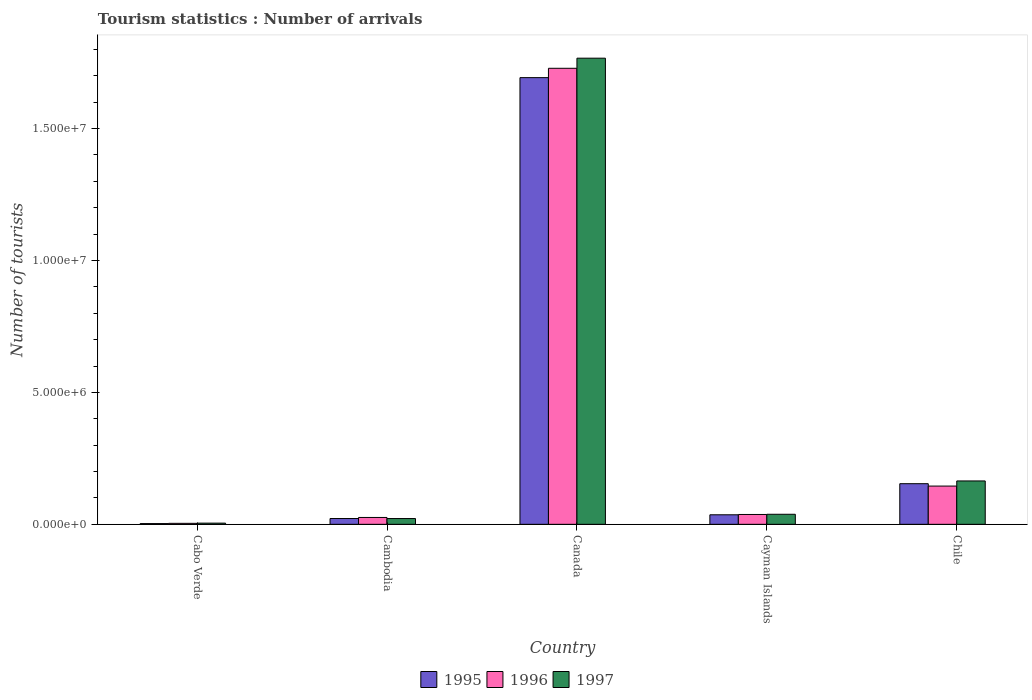Are the number of bars on each tick of the X-axis equal?
Your response must be concise. Yes. How many bars are there on the 1st tick from the left?
Offer a terse response. 3. What is the label of the 5th group of bars from the left?
Make the answer very short. Chile. What is the number of tourist arrivals in 1996 in Canada?
Your answer should be very brief. 1.73e+07. Across all countries, what is the maximum number of tourist arrivals in 1996?
Your answer should be compact. 1.73e+07. Across all countries, what is the minimum number of tourist arrivals in 1996?
Your answer should be compact. 3.70e+04. In which country was the number of tourist arrivals in 1995 minimum?
Offer a terse response. Cabo Verde. What is the total number of tourist arrivals in 1996 in the graph?
Offer a very short reply. 1.94e+07. What is the difference between the number of tourist arrivals in 1997 in Cabo Verde and that in Cambodia?
Ensure brevity in your answer.  -1.74e+05. What is the difference between the number of tourist arrivals in 1996 in Canada and the number of tourist arrivals in 1997 in Chile?
Your response must be concise. 1.56e+07. What is the average number of tourist arrivals in 1996 per country?
Keep it short and to the point. 3.88e+06. What is the difference between the number of tourist arrivals of/in 1996 and number of tourist arrivals of/in 1995 in Chile?
Make the answer very short. -9.00e+04. What is the ratio of the number of tourist arrivals in 1996 in Cambodia to that in Cayman Islands?
Keep it short and to the point. 0.7. Is the difference between the number of tourist arrivals in 1996 in Cayman Islands and Chile greater than the difference between the number of tourist arrivals in 1995 in Cayman Islands and Chile?
Make the answer very short. Yes. What is the difference between the highest and the second highest number of tourist arrivals in 1997?
Offer a terse response. 1.73e+07. What is the difference between the highest and the lowest number of tourist arrivals in 1997?
Offer a terse response. 1.76e+07. Is the sum of the number of tourist arrivals in 1995 in Canada and Chile greater than the maximum number of tourist arrivals in 1997 across all countries?
Your answer should be very brief. Yes. Is it the case that in every country, the sum of the number of tourist arrivals in 1997 and number of tourist arrivals in 1996 is greater than the number of tourist arrivals in 1995?
Your answer should be compact. Yes. Are all the bars in the graph horizontal?
Offer a terse response. No. How many countries are there in the graph?
Your response must be concise. 5. Are the values on the major ticks of Y-axis written in scientific E-notation?
Ensure brevity in your answer.  Yes. Does the graph contain any zero values?
Give a very brief answer. No. Does the graph contain grids?
Offer a very short reply. No. How many legend labels are there?
Make the answer very short. 3. How are the legend labels stacked?
Ensure brevity in your answer.  Horizontal. What is the title of the graph?
Give a very brief answer. Tourism statistics : Number of arrivals. Does "1969" appear as one of the legend labels in the graph?
Ensure brevity in your answer.  No. What is the label or title of the X-axis?
Make the answer very short. Country. What is the label or title of the Y-axis?
Offer a terse response. Number of tourists. What is the Number of tourists in 1995 in Cabo Verde?
Your answer should be compact. 2.80e+04. What is the Number of tourists of 1996 in Cabo Verde?
Your answer should be compact. 3.70e+04. What is the Number of tourists of 1997 in Cabo Verde?
Offer a terse response. 4.50e+04. What is the Number of tourists in 1997 in Cambodia?
Provide a short and direct response. 2.19e+05. What is the Number of tourists in 1995 in Canada?
Offer a very short reply. 1.69e+07. What is the Number of tourists of 1996 in Canada?
Provide a succinct answer. 1.73e+07. What is the Number of tourists of 1997 in Canada?
Your response must be concise. 1.77e+07. What is the Number of tourists of 1995 in Cayman Islands?
Provide a succinct answer. 3.61e+05. What is the Number of tourists in 1996 in Cayman Islands?
Offer a very short reply. 3.73e+05. What is the Number of tourists of 1997 in Cayman Islands?
Provide a short and direct response. 3.81e+05. What is the Number of tourists in 1995 in Chile?
Give a very brief answer. 1.54e+06. What is the Number of tourists in 1996 in Chile?
Your response must be concise. 1.45e+06. What is the Number of tourists in 1997 in Chile?
Provide a succinct answer. 1.64e+06. Across all countries, what is the maximum Number of tourists of 1995?
Provide a succinct answer. 1.69e+07. Across all countries, what is the maximum Number of tourists in 1996?
Make the answer very short. 1.73e+07. Across all countries, what is the maximum Number of tourists in 1997?
Your answer should be compact. 1.77e+07. Across all countries, what is the minimum Number of tourists in 1995?
Ensure brevity in your answer.  2.80e+04. Across all countries, what is the minimum Number of tourists in 1996?
Your answer should be very brief. 3.70e+04. Across all countries, what is the minimum Number of tourists in 1997?
Give a very brief answer. 4.50e+04. What is the total Number of tourists in 1995 in the graph?
Provide a short and direct response. 1.91e+07. What is the total Number of tourists of 1996 in the graph?
Offer a very short reply. 1.94e+07. What is the total Number of tourists in 1997 in the graph?
Provide a short and direct response. 2.00e+07. What is the difference between the Number of tourists of 1995 in Cabo Verde and that in Cambodia?
Your response must be concise. -1.92e+05. What is the difference between the Number of tourists in 1996 in Cabo Verde and that in Cambodia?
Your answer should be very brief. -2.23e+05. What is the difference between the Number of tourists in 1997 in Cabo Verde and that in Cambodia?
Your answer should be very brief. -1.74e+05. What is the difference between the Number of tourists of 1995 in Cabo Verde and that in Canada?
Keep it short and to the point. -1.69e+07. What is the difference between the Number of tourists of 1996 in Cabo Verde and that in Canada?
Offer a terse response. -1.72e+07. What is the difference between the Number of tourists of 1997 in Cabo Verde and that in Canada?
Your answer should be very brief. -1.76e+07. What is the difference between the Number of tourists in 1995 in Cabo Verde and that in Cayman Islands?
Keep it short and to the point. -3.33e+05. What is the difference between the Number of tourists of 1996 in Cabo Verde and that in Cayman Islands?
Keep it short and to the point. -3.36e+05. What is the difference between the Number of tourists in 1997 in Cabo Verde and that in Cayman Islands?
Keep it short and to the point. -3.36e+05. What is the difference between the Number of tourists in 1995 in Cabo Verde and that in Chile?
Your response must be concise. -1.51e+06. What is the difference between the Number of tourists of 1996 in Cabo Verde and that in Chile?
Offer a very short reply. -1.41e+06. What is the difference between the Number of tourists in 1997 in Cabo Verde and that in Chile?
Your response must be concise. -1.60e+06. What is the difference between the Number of tourists of 1995 in Cambodia and that in Canada?
Keep it short and to the point. -1.67e+07. What is the difference between the Number of tourists of 1996 in Cambodia and that in Canada?
Provide a succinct answer. -1.70e+07. What is the difference between the Number of tourists of 1997 in Cambodia and that in Canada?
Make the answer very short. -1.74e+07. What is the difference between the Number of tourists of 1995 in Cambodia and that in Cayman Islands?
Give a very brief answer. -1.41e+05. What is the difference between the Number of tourists in 1996 in Cambodia and that in Cayman Islands?
Ensure brevity in your answer.  -1.13e+05. What is the difference between the Number of tourists in 1997 in Cambodia and that in Cayman Islands?
Ensure brevity in your answer.  -1.62e+05. What is the difference between the Number of tourists in 1995 in Cambodia and that in Chile?
Provide a short and direct response. -1.32e+06. What is the difference between the Number of tourists of 1996 in Cambodia and that in Chile?
Your answer should be compact. -1.19e+06. What is the difference between the Number of tourists of 1997 in Cambodia and that in Chile?
Your response must be concise. -1.42e+06. What is the difference between the Number of tourists in 1995 in Canada and that in Cayman Islands?
Keep it short and to the point. 1.66e+07. What is the difference between the Number of tourists in 1996 in Canada and that in Cayman Islands?
Make the answer very short. 1.69e+07. What is the difference between the Number of tourists of 1997 in Canada and that in Cayman Islands?
Keep it short and to the point. 1.73e+07. What is the difference between the Number of tourists of 1995 in Canada and that in Chile?
Your answer should be compact. 1.54e+07. What is the difference between the Number of tourists of 1996 in Canada and that in Chile?
Keep it short and to the point. 1.58e+07. What is the difference between the Number of tourists in 1997 in Canada and that in Chile?
Offer a terse response. 1.60e+07. What is the difference between the Number of tourists in 1995 in Cayman Islands and that in Chile?
Provide a succinct answer. -1.18e+06. What is the difference between the Number of tourists of 1996 in Cayman Islands and that in Chile?
Give a very brief answer. -1.08e+06. What is the difference between the Number of tourists of 1997 in Cayman Islands and that in Chile?
Your response must be concise. -1.26e+06. What is the difference between the Number of tourists in 1995 in Cabo Verde and the Number of tourists in 1996 in Cambodia?
Offer a terse response. -2.32e+05. What is the difference between the Number of tourists of 1995 in Cabo Verde and the Number of tourists of 1997 in Cambodia?
Ensure brevity in your answer.  -1.91e+05. What is the difference between the Number of tourists of 1996 in Cabo Verde and the Number of tourists of 1997 in Cambodia?
Your answer should be very brief. -1.82e+05. What is the difference between the Number of tourists of 1995 in Cabo Verde and the Number of tourists of 1996 in Canada?
Offer a very short reply. -1.73e+07. What is the difference between the Number of tourists in 1995 in Cabo Verde and the Number of tourists in 1997 in Canada?
Ensure brevity in your answer.  -1.76e+07. What is the difference between the Number of tourists of 1996 in Cabo Verde and the Number of tourists of 1997 in Canada?
Keep it short and to the point. -1.76e+07. What is the difference between the Number of tourists in 1995 in Cabo Verde and the Number of tourists in 1996 in Cayman Islands?
Provide a succinct answer. -3.45e+05. What is the difference between the Number of tourists of 1995 in Cabo Verde and the Number of tourists of 1997 in Cayman Islands?
Make the answer very short. -3.53e+05. What is the difference between the Number of tourists in 1996 in Cabo Verde and the Number of tourists in 1997 in Cayman Islands?
Make the answer very short. -3.44e+05. What is the difference between the Number of tourists in 1995 in Cabo Verde and the Number of tourists in 1996 in Chile?
Ensure brevity in your answer.  -1.42e+06. What is the difference between the Number of tourists of 1995 in Cabo Verde and the Number of tourists of 1997 in Chile?
Your response must be concise. -1.62e+06. What is the difference between the Number of tourists of 1996 in Cabo Verde and the Number of tourists of 1997 in Chile?
Provide a succinct answer. -1.61e+06. What is the difference between the Number of tourists of 1995 in Cambodia and the Number of tourists of 1996 in Canada?
Keep it short and to the point. -1.71e+07. What is the difference between the Number of tourists in 1995 in Cambodia and the Number of tourists in 1997 in Canada?
Offer a very short reply. -1.74e+07. What is the difference between the Number of tourists in 1996 in Cambodia and the Number of tourists in 1997 in Canada?
Give a very brief answer. -1.74e+07. What is the difference between the Number of tourists in 1995 in Cambodia and the Number of tourists in 1996 in Cayman Islands?
Give a very brief answer. -1.53e+05. What is the difference between the Number of tourists of 1995 in Cambodia and the Number of tourists of 1997 in Cayman Islands?
Your answer should be very brief. -1.61e+05. What is the difference between the Number of tourists in 1996 in Cambodia and the Number of tourists in 1997 in Cayman Islands?
Offer a very short reply. -1.21e+05. What is the difference between the Number of tourists in 1995 in Cambodia and the Number of tourists in 1996 in Chile?
Keep it short and to the point. -1.23e+06. What is the difference between the Number of tourists of 1995 in Cambodia and the Number of tourists of 1997 in Chile?
Your answer should be compact. -1.42e+06. What is the difference between the Number of tourists in 1996 in Cambodia and the Number of tourists in 1997 in Chile?
Your answer should be very brief. -1.38e+06. What is the difference between the Number of tourists in 1995 in Canada and the Number of tourists in 1996 in Cayman Islands?
Keep it short and to the point. 1.66e+07. What is the difference between the Number of tourists of 1995 in Canada and the Number of tourists of 1997 in Cayman Islands?
Offer a terse response. 1.66e+07. What is the difference between the Number of tourists of 1996 in Canada and the Number of tourists of 1997 in Cayman Islands?
Provide a succinct answer. 1.69e+07. What is the difference between the Number of tourists in 1995 in Canada and the Number of tourists in 1996 in Chile?
Provide a succinct answer. 1.55e+07. What is the difference between the Number of tourists in 1995 in Canada and the Number of tourists in 1997 in Chile?
Ensure brevity in your answer.  1.53e+07. What is the difference between the Number of tourists of 1996 in Canada and the Number of tourists of 1997 in Chile?
Make the answer very short. 1.56e+07. What is the difference between the Number of tourists in 1995 in Cayman Islands and the Number of tourists in 1996 in Chile?
Provide a succinct answer. -1.09e+06. What is the difference between the Number of tourists of 1995 in Cayman Islands and the Number of tourists of 1997 in Chile?
Your answer should be compact. -1.28e+06. What is the difference between the Number of tourists in 1996 in Cayman Islands and the Number of tourists in 1997 in Chile?
Your response must be concise. -1.27e+06. What is the average Number of tourists of 1995 per country?
Provide a succinct answer. 3.82e+06. What is the average Number of tourists of 1996 per country?
Provide a short and direct response. 3.88e+06. What is the average Number of tourists in 1997 per country?
Your response must be concise. 3.99e+06. What is the difference between the Number of tourists of 1995 and Number of tourists of 1996 in Cabo Verde?
Your response must be concise. -9000. What is the difference between the Number of tourists in 1995 and Number of tourists in 1997 in Cabo Verde?
Your response must be concise. -1.70e+04. What is the difference between the Number of tourists of 1996 and Number of tourists of 1997 in Cabo Verde?
Keep it short and to the point. -8000. What is the difference between the Number of tourists of 1995 and Number of tourists of 1996 in Cambodia?
Your answer should be compact. -4.00e+04. What is the difference between the Number of tourists of 1995 and Number of tourists of 1997 in Cambodia?
Ensure brevity in your answer.  1000. What is the difference between the Number of tourists in 1996 and Number of tourists in 1997 in Cambodia?
Provide a succinct answer. 4.10e+04. What is the difference between the Number of tourists in 1995 and Number of tourists in 1996 in Canada?
Offer a very short reply. -3.54e+05. What is the difference between the Number of tourists in 1995 and Number of tourists in 1997 in Canada?
Make the answer very short. -7.37e+05. What is the difference between the Number of tourists in 1996 and Number of tourists in 1997 in Canada?
Offer a very short reply. -3.83e+05. What is the difference between the Number of tourists of 1995 and Number of tourists of 1996 in Cayman Islands?
Offer a terse response. -1.20e+04. What is the difference between the Number of tourists in 1995 and Number of tourists in 1997 in Cayman Islands?
Your answer should be compact. -2.00e+04. What is the difference between the Number of tourists in 1996 and Number of tourists in 1997 in Cayman Islands?
Your answer should be compact. -8000. What is the difference between the Number of tourists of 1995 and Number of tourists of 1996 in Chile?
Offer a very short reply. 9.00e+04. What is the difference between the Number of tourists in 1995 and Number of tourists in 1997 in Chile?
Ensure brevity in your answer.  -1.04e+05. What is the difference between the Number of tourists in 1996 and Number of tourists in 1997 in Chile?
Provide a short and direct response. -1.94e+05. What is the ratio of the Number of tourists of 1995 in Cabo Verde to that in Cambodia?
Give a very brief answer. 0.13. What is the ratio of the Number of tourists in 1996 in Cabo Verde to that in Cambodia?
Your response must be concise. 0.14. What is the ratio of the Number of tourists of 1997 in Cabo Verde to that in Cambodia?
Your response must be concise. 0.21. What is the ratio of the Number of tourists of 1995 in Cabo Verde to that in Canada?
Your answer should be very brief. 0. What is the ratio of the Number of tourists of 1996 in Cabo Verde to that in Canada?
Your answer should be very brief. 0. What is the ratio of the Number of tourists in 1997 in Cabo Verde to that in Canada?
Your response must be concise. 0. What is the ratio of the Number of tourists in 1995 in Cabo Verde to that in Cayman Islands?
Ensure brevity in your answer.  0.08. What is the ratio of the Number of tourists in 1996 in Cabo Verde to that in Cayman Islands?
Your response must be concise. 0.1. What is the ratio of the Number of tourists of 1997 in Cabo Verde to that in Cayman Islands?
Keep it short and to the point. 0.12. What is the ratio of the Number of tourists of 1995 in Cabo Verde to that in Chile?
Offer a very short reply. 0.02. What is the ratio of the Number of tourists in 1996 in Cabo Verde to that in Chile?
Make the answer very short. 0.03. What is the ratio of the Number of tourists in 1997 in Cabo Verde to that in Chile?
Keep it short and to the point. 0.03. What is the ratio of the Number of tourists in 1995 in Cambodia to that in Canada?
Give a very brief answer. 0.01. What is the ratio of the Number of tourists of 1996 in Cambodia to that in Canada?
Offer a very short reply. 0.01. What is the ratio of the Number of tourists in 1997 in Cambodia to that in Canada?
Ensure brevity in your answer.  0.01. What is the ratio of the Number of tourists in 1995 in Cambodia to that in Cayman Islands?
Give a very brief answer. 0.61. What is the ratio of the Number of tourists of 1996 in Cambodia to that in Cayman Islands?
Your answer should be very brief. 0.7. What is the ratio of the Number of tourists of 1997 in Cambodia to that in Cayman Islands?
Make the answer very short. 0.57. What is the ratio of the Number of tourists in 1995 in Cambodia to that in Chile?
Your answer should be compact. 0.14. What is the ratio of the Number of tourists of 1996 in Cambodia to that in Chile?
Offer a terse response. 0.18. What is the ratio of the Number of tourists of 1997 in Cambodia to that in Chile?
Ensure brevity in your answer.  0.13. What is the ratio of the Number of tourists in 1995 in Canada to that in Cayman Islands?
Keep it short and to the point. 46.9. What is the ratio of the Number of tourists in 1996 in Canada to that in Cayman Islands?
Provide a short and direct response. 46.34. What is the ratio of the Number of tourists of 1997 in Canada to that in Cayman Islands?
Provide a short and direct response. 46.38. What is the ratio of the Number of tourists of 1995 in Canada to that in Chile?
Provide a short and direct response. 10.99. What is the ratio of the Number of tourists in 1996 in Canada to that in Chile?
Your answer should be very brief. 11.92. What is the ratio of the Number of tourists of 1997 in Canada to that in Chile?
Ensure brevity in your answer.  10.75. What is the ratio of the Number of tourists in 1995 in Cayman Islands to that in Chile?
Your answer should be compact. 0.23. What is the ratio of the Number of tourists in 1996 in Cayman Islands to that in Chile?
Make the answer very short. 0.26. What is the ratio of the Number of tourists of 1997 in Cayman Islands to that in Chile?
Give a very brief answer. 0.23. What is the difference between the highest and the second highest Number of tourists in 1995?
Offer a terse response. 1.54e+07. What is the difference between the highest and the second highest Number of tourists in 1996?
Provide a succinct answer. 1.58e+07. What is the difference between the highest and the second highest Number of tourists in 1997?
Give a very brief answer. 1.60e+07. What is the difference between the highest and the lowest Number of tourists in 1995?
Your answer should be very brief. 1.69e+07. What is the difference between the highest and the lowest Number of tourists of 1996?
Provide a succinct answer. 1.72e+07. What is the difference between the highest and the lowest Number of tourists of 1997?
Keep it short and to the point. 1.76e+07. 